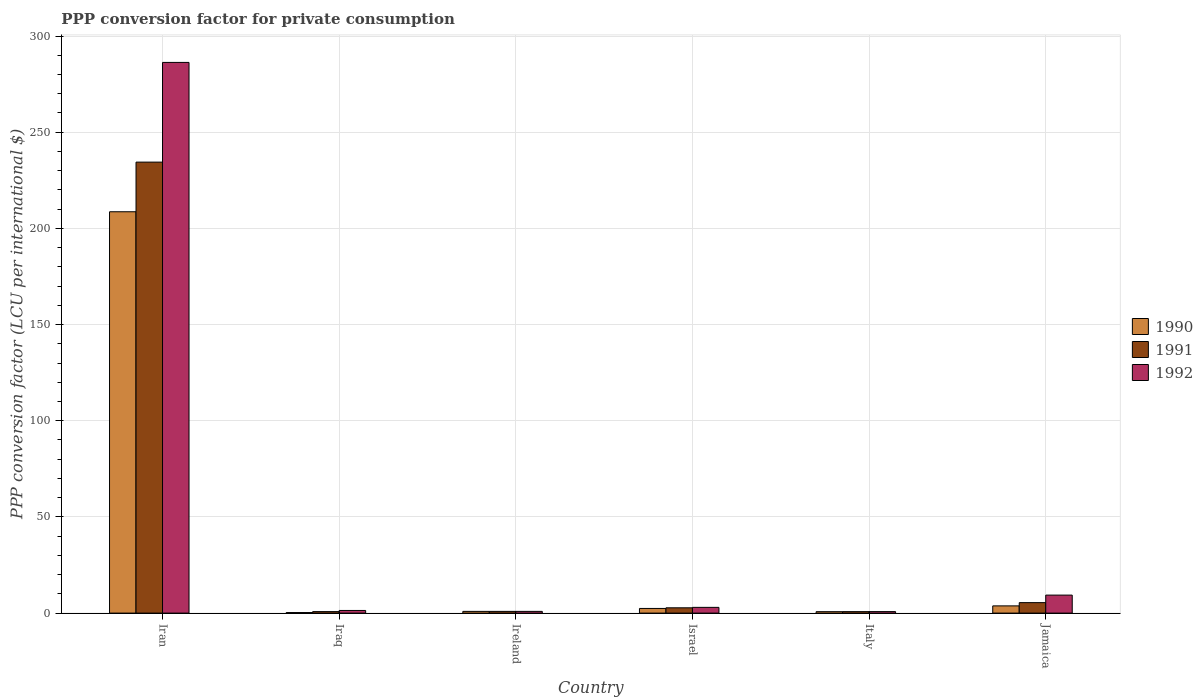Are the number of bars per tick equal to the number of legend labels?
Offer a terse response. Yes. How many bars are there on the 5th tick from the left?
Make the answer very short. 3. What is the label of the 3rd group of bars from the left?
Your answer should be very brief. Ireland. In how many cases, is the number of bars for a given country not equal to the number of legend labels?
Offer a terse response. 0. What is the PPP conversion factor for private consumption in 1991 in Jamaica?
Your response must be concise. 5.44. Across all countries, what is the maximum PPP conversion factor for private consumption in 1990?
Provide a succinct answer. 208.65. Across all countries, what is the minimum PPP conversion factor for private consumption in 1992?
Ensure brevity in your answer.  0.78. In which country was the PPP conversion factor for private consumption in 1990 maximum?
Offer a terse response. Iran. In which country was the PPP conversion factor for private consumption in 1991 minimum?
Your response must be concise. Italy. What is the total PPP conversion factor for private consumption in 1991 in the graph?
Make the answer very short. 245.06. What is the difference between the PPP conversion factor for private consumption in 1991 in Iran and that in Iraq?
Your response must be concise. 233.69. What is the difference between the PPP conversion factor for private consumption in 1990 in Israel and the PPP conversion factor for private consumption in 1992 in Jamaica?
Offer a terse response. -6.94. What is the average PPP conversion factor for private consumption in 1991 per country?
Your answer should be compact. 40.84. What is the difference between the PPP conversion factor for private consumption of/in 1991 and PPP conversion factor for private consumption of/in 1990 in Jamaica?
Ensure brevity in your answer.  1.69. In how many countries, is the PPP conversion factor for private consumption in 1992 greater than 100 LCU?
Your answer should be compact. 1. What is the ratio of the PPP conversion factor for private consumption in 1990 in Iran to that in Iraq?
Offer a very short reply. 731.55. Is the difference between the PPP conversion factor for private consumption in 1991 in Israel and Italy greater than the difference between the PPP conversion factor for private consumption in 1990 in Israel and Italy?
Your answer should be very brief. Yes. What is the difference between the highest and the second highest PPP conversion factor for private consumption in 1991?
Give a very brief answer. 231.71. What is the difference between the highest and the lowest PPP conversion factor for private consumption in 1991?
Make the answer very short. 233.7. In how many countries, is the PPP conversion factor for private consumption in 1990 greater than the average PPP conversion factor for private consumption in 1990 taken over all countries?
Give a very brief answer. 1. Is the sum of the PPP conversion factor for private consumption in 1992 in Iraq and Israel greater than the maximum PPP conversion factor for private consumption in 1991 across all countries?
Your answer should be very brief. No. What does the 1st bar from the left in Israel represents?
Your answer should be very brief. 1990. What does the 2nd bar from the right in Italy represents?
Make the answer very short. 1991. Is it the case that in every country, the sum of the PPP conversion factor for private consumption in 1990 and PPP conversion factor for private consumption in 1991 is greater than the PPP conversion factor for private consumption in 1992?
Offer a very short reply. No. How many bars are there?
Your answer should be compact. 18. Are all the bars in the graph horizontal?
Your answer should be very brief. No. How many countries are there in the graph?
Your answer should be compact. 6. What is the difference between two consecutive major ticks on the Y-axis?
Give a very brief answer. 50. Are the values on the major ticks of Y-axis written in scientific E-notation?
Offer a terse response. No. Does the graph contain grids?
Give a very brief answer. Yes. What is the title of the graph?
Provide a succinct answer. PPP conversion factor for private consumption. Does "1982" appear as one of the legend labels in the graph?
Offer a very short reply. No. What is the label or title of the X-axis?
Provide a succinct answer. Country. What is the label or title of the Y-axis?
Your answer should be very brief. PPP conversion factor (LCU per international $). What is the PPP conversion factor (LCU per international $) of 1990 in Iran?
Your response must be concise. 208.65. What is the PPP conversion factor (LCU per international $) in 1991 in Iran?
Provide a short and direct response. 234.46. What is the PPP conversion factor (LCU per international $) of 1992 in Iran?
Your answer should be compact. 286.29. What is the PPP conversion factor (LCU per international $) of 1990 in Iraq?
Your answer should be very brief. 0.29. What is the PPP conversion factor (LCU per international $) of 1991 in Iraq?
Your answer should be compact. 0.77. What is the PPP conversion factor (LCU per international $) in 1992 in Iraq?
Your response must be concise. 1.37. What is the PPP conversion factor (LCU per international $) of 1990 in Ireland?
Keep it short and to the point. 0.9. What is the PPP conversion factor (LCU per international $) in 1991 in Ireland?
Provide a short and direct response. 0.89. What is the PPP conversion factor (LCU per international $) of 1992 in Ireland?
Give a very brief answer. 0.89. What is the PPP conversion factor (LCU per international $) of 1990 in Israel?
Offer a terse response. 2.42. What is the PPP conversion factor (LCU per international $) of 1991 in Israel?
Ensure brevity in your answer.  2.75. What is the PPP conversion factor (LCU per international $) in 1992 in Israel?
Keep it short and to the point. 2.98. What is the PPP conversion factor (LCU per international $) in 1990 in Italy?
Offer a very short reply. 0.73. What is the PPP conversion factor (LCU per international $) in 1991 in Italy?
Your answer should be very brief. 0.76. What is the PPP conversion factor (LCU per international $) of 1992 in Italy?
Offer a terse response. 0.78. What is the PPP conversion factor (LCU per international $) of 1990 in Jamaica?
Offer a terse response. 3.75. What is the PPP conversion factor (LCU per international $) in 1991 in Jamaica?
Make the answer very short. 5.44. What is the PPP conversion factor (LCU per international $) of 1992 in Jamaica?
Provide a short and direct response. 9.36. Across all countries, what is the maximum PPP conversion factor (LCU per international $) in 1990?
Provide a succinct answer. 208.65. Across all countries, what is the maximum PPP conversion factor (LCU per international $) of 1991?
Ensure brevity in your answer.  234.46. Across all countries, what is the maximum PPP conversion factor (LCU per international $) in 1992?
Offer a terse response. 286.29. Across all countries, what is the minimum PPP conversion factor (LCU per international $) in 1990?
Your answer should be compact. 0.29. Across all countries, what is the minimum PPP conversion factor (LCU per international $) of 1991?
Keep it short and to the point. 0.76. Across all countries, what is the minimum PPP conversion factor (LCU per international $) in 1992?
Your answer should be very brief. 0.78. What is the total PPP conversion factor (LCU per international $) of 1990 in the graph?
Your response must be concise. 216.73. What is the total PPP conversion factor (LCU per international $) of 1991 in the graph?
Provide a succinct answer. 245.06. What is the total PPP conversion factor (LCU per international $) in 1992 in the graph?
Give a very brief answer. 301.67. What is the difference between the PPP conversion factor (LCU per international $) of 1990 in Iran and that in Iraq?
Your answer should be very brief. 208.36. What is the difference between the PPP conversion factor (LCU per international $) of 1991 in Iran and that in Iraq?
Offer a terse response. 233.69. What is the difference between the PPP conversion factor (LCU per international $) in 1992 in Iran and that in Iraq?
Your response must be concise. 284.92. What is the difference between the PPP conversion factor (LCU per international $) of 1990 in Iran and that in Ireland?
Make the answer very short. 207.75. What is the difference between the PPP conversion factor (LCU per international $) in 1991 in Iran and that in Ireland?
Your answer should be compact. 233.57. What is the difference between the PPP conversion factor (LCU per international $) in 1992 in Iran and that in Ireland?
Keep it short and to the point. 285.4. What is the difference between the PPP conversion factor (LCU per international $) in 1990 in Iran and that in Israel?
Provide a succinct answer. 206.23. What is the difference between the PPP conversion factor (LCU per international $) in 1991 in Iran and that in Israel?
Give a very brief answer. 231.71. What is the difference between the PPP conversion factor (LCU per international $) of 1992 in Iran and that in Israel?
Ensure brevity in your answer.  283.31. What is the difference between the PPP conversion factor (LCU per international $) in 1990 in Iran and that in Italy?
Offer a terse response. 207.91. What is the difference between the PPP conversion factor (LCU per international $) of 1991 in Iran and that in Italy?
Your response must be concise. 233.7. What is the difference between the PPP conversion factor (LCU per international $) in 1992 in Iran and that in Italy?
Offer a very short reply. 285.51. What is the difference between the PPP conversion factor (LCU per international $) of 1990 in Iran and that in Jamaica?
Your response must be concise. 204.9. What is the difference between the PPP conversion factor (LCU per international $) of 1991 in Iran and that in Jamaica?
Make the answer very short. 229.02. What is the difference between the PPP conversion factor (LCU per international $) in 1992 in Iran and that in Jamaica?
Make the answer very short. 276.94. What is the difference between the PPP conversion factor (LCU per international $) of 1990 in Iraq and that in Ireland?
Your response must be concise. -0.61. What is the difference between the PPP conversion factor (LCU per international $) of 1991 in Iraq and that in Ireland?
Offer a terse response. -0.12. What is the difference between the PPP conversion factor (LCU per international $) in 1992 in Iraq and that in Ireland?
Your response must be concise. 0.48. What is the difference between the PPP conversion factor (LCU per international $) of 1990 in Iraq and that in Israel?
Keep it short and to the point. -2.13. What is the difference between the PPP conversion factor (LCU per international $) in 1991 in Iraq and that in Israel?
Offer a very short reply. -1.98. What is the difference between the PPP conversion factor (LCU per international $) of 1992 in Iraq and that in Israel?
Provide a succinct answer. -1.61. What is the difference between the PPP conversion factor (LCU per international $) in 1990 in Iraq and that in Italy?
Your answer should be compact. -0.45. What is the difference between the PPP conversion factor (LCU per international $) in 1991 in Iraq and that in Italy?
Offer a very short reply. 0.01. What is the difference between the PPP conversion factor (LCU per international $) in 1992 in Iraq and that in Italy?
Your answer should be compact. 0.59. What is the difference between the PPP conversion factor (LCU per international $) of 1990 in Iraq and that in Jamaica?
Ensure brevity in your answer.  -3.47. What is the difference between the PPP conversion factor (LCU per international $) in 1991 in Iraq and that in Jamaica?
Offer a terse response. -4.67. What is the difference between the PPP conversion factor (LCU per international $) in 1992 in Iraq and that in Jamaica?
Keep it short and to the point. -7.99. What is the difference between the PPP conversion factor (LCU per international $) of 1990 in Ireland and that in Israel?
Your response must be concise. -1.52. What is the difference between the PPP conversion factor (LCU per international $) of 1991 in Ireland and that in Israel?
Offer a terse response. -1.86. What is the difference between the PPP conversion factor (LCU per international $) in 1992 in Ireland and that in Israel?
Offer a terse response. -2.09. What is the difference between the PPP conversion factor (LCU per international $) in 1990 in Ireland and that in Italy?
Your response must be concise. 0.16. What is the difference between the PPP conversion factor (LCU per international $) in 1991 in Ireland and that in Italy?
Provide a succinct answer. 0.13. What is the difference between the PPP conversion factor (LCU per international $) of 1992 in Ireland and that in Italy?
Give a very brief answer. 0.12. What is the difference between the PPP conversion factor (LCU per international $) of 1990 in Ireland and that in Jamaica?
Provide a succinct answer. -2.86. What is the difference between the PPP conversion factor (LCU per international $) of 1991 in Ireland and that in Jamaica?
Offer a very short reply. -4.55. What is the difference between the PPP conversion factor (LCU per international $) of 1992 in Ireland and that in Jamaica?
Your answer should be compact. -8.46. What is the difference between the PPP conversion factor (LCU per international $) in 1990 in Israel and that in Italy?
Your answer should be compact. 1.69. What is the difference between the PPP conversion factor (LCU per international $) in 1991 in Israel and that in Italy?
Your answer should be compact. 1.99. What is the difference between the PPP conversion factor (LCU per international $) in 1992 in Israel and that in Italy?
Ensure brevity in your answer.  2.2. What is the difference between the PPP conversion factor (LCU per international $) of 1990 in Israel and that in Jamaica?
Provide a succinct answer. -1.33. What is the difference between the PPP conversion factor (LCU per international $) of 1991 in Israel and that in Jamaica?
Keep it short and to the point. -2.69. What is the difference between the PPP conversion factor (LCU per international $) in 1992 in Israel and that in Jamaica?
Offer a very short reply. -6.38. What is the difference between the PPP conversion factor (LCU per international $) of 1990 in Italy and that in Jamaica?
Make the answer very short. -3.02. What is the difference between the PPP conversion factor (LCU per international $) of 1991 in Italy and that in Jamaica?
Your response must be concise. -4.68. What is the difference between the PPP conversion factor (LCU per international $) of 1992 in Italy and that in Jamaica?
Keep it short and to the point. -8.58. What is the difference between the PPP conversion factor (LCU per international $) in 1990 in Iran and the PPP conversion factor (LCU per international $) in 1991 in Iraq?
Give a very brief answer. 207.88. What is the difference between the PPP conversion factor (LCU per international $) of 1990 in Iran and the PPP conversion factor (LCU per international $) of 1992 in Iraq?
Keep it short and to the point. 207.28. What is the difference between the PPP conversion factor (LCU per international $) in 1991 in Iran and the PPP conversion factor (LCU per international $) in 1992 in Iraq?
Keep it short and to the point. 233.09. What is the difference between the PPP conversion factor (LCU per international $) of 1990 in Iran and the PPP conversion factor (LCU per international $) of 1991 in Ireland?
Ensure brevity in your answer.  207.76. What is the difference between the PPP conversion factor (LCU per international $) in 1990 in Iran and the PPP conversion factor (LCU per international $) in 1992 in Ireland?
Keep it short and to the point. 207.75. What is the difference between the PPP conversion factor (LCU per international $) in 1991 in Iran and the PPP conversion factor (LCU per international $) in 1992 in Ireland?
Ensure brevity in your answer.  233.56. What is the difference between the PPP conversion factor (LCU per international $) of 1990 in Iran and the PPP conversion factor (LCU per international $) of 1991 in Israel?
Offer a terse response. 205.9. What is the difference between the PPP conversion factor (LCU per international $) in 1990 in Iran and the PPP conversion factor (LCU per international $) in 1992 in Israel?
Offer a terse response. 205.67. What is the difference between the PPP conversion factor (LCU per international $) of 1991 in Iran and the PPP conversion factor (LCU per international $) of 1992 in Israel?
Provide a succinct answer. 231.48. What is the difference between the PPP conversion factor (LCU per international $) of 1990 in Iran and the PPP conversion factor (LCU per international $) of 1991 in Italy?
Provide a succinct answer. 207.89. What is the difference between the PPP conversion factor (LCU per international $) in 1990 in Iran and the PPP conversion factor (LCU per international $) in 1992 in Italy?
Offer a very short reply. 207.87. What is the difference between the PPP conversion factor (LCU per international $) in 1991 in Iran and the PPP conversion factor (LCU per international $) in 1992 in Italy?
Make the answer very short. 233.68. What is the difference between the PPP conversion factor (LCU per international $) in 1990 in Iran and the PPP conversion factor (LCU per international $) in 1991 in Jamaica?
Ensure brevity in your answer.  203.21. What is the difference between the PPP conversion factor (LCU per international $) of 1990 in Iran and the PPP conversion factor (LCU per international $) of 1992 in Jamaica?
Offer a very short reply. 199.29. What is the difference between the PPP conversion factor (LCU per international $) in 1991 in Iran and the PPP conversion factor (LCU per international $) in 1992 in Jamaica?
Offer a very short reply. 225.1. What is the difference between the PPP conversion factor (LCU per international $) in 1990 in Iraq and the PPP conversion factor (LCU per international $) in 1991 in Ireland?
Give a very brief answer. -0.61. What is the difference between the PPP conversion factor (LCU per international $) in 1990 in Iraq and the PPP conversion factor (LCU per international $) in 1992 in Ireland?
Your answer should be very brief. -0.61. What is the difference between the PPP conversion factor (LCU per international $) in 1991 in Iraq and the PPP conversion factor (LCU per international $) in 1992 in Ireland?
Offer a very short reply. -0.12. What is the difference between the PPP conversion factor (LCU per international $) of 1990 in Iraq and the PPP conversion factor (LCU per international $) of 1991 in Israel?
Keep it short and to the point. -2.46. What is the difference between the PPP conversion factor (LCU per international $) of 1990 in Iraq and the PPP conversion factor (LCU per international $) of 1992 in Israel?
Ensure brevity in your answer.  -2.7. What is the difference between the PPP conversion factor (LCU per international $) in 1991 in Iraq and the PPP conversion factor (LCU per international $) in 1992 in Israel?
Keep it short and to the point. -2.21. What is the difference between the PPP conversion factor (LCU per international $) of 1990 in Iraq and the PPP conversion factor (LCU per international $) of 1991 in Italy?
Your response must be concise. -0.47. What is the difference between the PPP conversion factor (LCU per international $) in 1990 in Iraq and the PPP conversion factor (LCU per international $) in 1992 in Italy?
Provide a short and direct response. -0.49. What is the difference between the PPP conversion factor (LCU per international $) of 1991 in Iraq and the PPP conversion factor (LCU per international $) of 1992 in Italy?
Your answer should be compact. -0.01. What is the difference between the PPP conversion factor (LCU per international $) in 1990 in Iraq and the PPP conversion factor (LCU per international $) in 1991 in Jamaica?
Your response must be concise. -5.15. What is the difference between the PPP conversion factor (LCU per international $) of 1990 in Iraq and the PPP conversion factor (LCU per international $) of 1992 in Jamaica?
Your response must be concise. -9.07. What is the difference between the PPP conversion factor (LCU per international $) of 1991 in Iraq and the PPP conversion factor (LCU per international $) of 1992 in Jamaica?
Your answer should be compact. -8.59. What is the difference between the PPP conversion factor (LCU per international $) in 1990 in Ireland and the PPP conversion factor (LCU per international $) in 1991 in Israel?
Offer a very short reply. -1.85. What is the difference between the PPP conversion factor (LCU per international $) in 1990 in Ireland and the PPP conversion factor (LCU per international $) in 1992 in Israel?
Make the answer very short. -2.08. What is the difference between the PPP conversion factor (LCU per international $) of 1991 in Ireland and the PPP conversion factor (LCU per international $) of 1992 in Israel?
Ensure brevity in your answer.  -2.09. What is the difference between the PPP conversion factor (LCU per international $) in 1990 in Ireland and the PPP conversion factor (LCU per international $) in 1991 in Italy?
Offer a terse response. 0.14. What is the difference between the PPP conversion factor (LCU per international $) of 1990 in Ireland and the PPP conversion factor (LCU per international $) of 1992 in Italy?
Offer a terse response. 0.12. What is the difference between the PPP conversion factor (LCU per international $) in 1991 in Ireland and the PPP conversion factor (LCU per international $) in 1992 in Italy?
Give a very brief answer. 0.11. What is the difference between the PPP conversion factor (LCU per international $) of 1990 in Ireland and the PPP conversion factor (LCU per international $) of 1991 in Jamaica?
Keep it short and to the point. -4.54. What is the difference between the PPP conversion factor (LCU per international $) in 1990 in Ireland and the PPP conversion factor (LCU per international $) in 1992 in Jamaica?
Make the answer very short. -8.46. What is the difference between the PPP conversion factor (LCU per international $) in 1991 in Ireland and the PPP conversion factor (LCU per international $) in 1992 in Jamaica?
Offer a terse response. -8.47. What is the difference between the PPP conversion factor (LCU per international $) in 1990 in Israel and the PPP conversion factor (LCU per international $) in 1991 in Italy?
Provide a short and direct response. 1.66. What is the difference between the PPP conversion factor (LCU per international $) of 1990 in Israel and the PPP conversion factor (LCU per international $) of 1992 in Italy?
Your answer should be very brief. 1.64. What is the difference between the PPP conversion factor (LCU per international $) in 1991 in Israel and the PPP conversion factor (LCU per international $) in 1992 in Italy?
Provide a succinct answer. 1.97. What is the difference between the PPP conversion factor (LCU per international $) of 1990 in Israel and the PPP conversion factor (LCU per international $) of 1991 in Jamaica?
Make the answer very short. -3.02. What is the difference between the PPP conversion factor (LCU per international $) in 1990 in Israel and the PPP conversion factor (LCU per international $) in 1992 in Jamaica?
Offer a terse response. -6.94. What is the difference between the PPP conversion factor (LCU per international $) in 1991 in Israel and the PPP conversion factor (LCU per international $) in 1992 in Jamaica?
Your answer should be very brief. -6.61. What is the difference between the PPP conversion factor (LCU per international $) of 1990 in Italy and the PPP conversion factor (LCU per international $) of 1991 in Jamaica?
Offer a very short reply. -4.7. What is the difference between the PPP conversion factor (LCU per international $) in 1990 in Italy and the PPP conversion factor (LCU per international $) in 1992 in Jamaica?
Offer a very short reply. -8.62. What is the difference between the PPP conversion factor (LCU per international $) in 1991 in Italy and the PPP conversion factor (LCU per international $) in 1992 in Jamaica?
Make the answer very short. -8.6. What is the average PPP conversion factor (LCU per international $) of 1990 per country?
Ensure brevity in your answer.  36.12. What is the average PPP conversion factor (LCU per international $) in 1991 per country?
Your answer should be very brief. 40.84. What is the average PPP conversion factor (LCU per international $) of 1992 per country?
Your answer should be compact. 50.28. What is the difference between the PPP conversion factor (LCU per international $) in 1990 and PPP conversion factor (LCU per international $) in 1991 in Iran?
Give a very brief answer. -25.81. What is the difference between the PPP conversion factor (LCU per international $) of 1990 and PPP conversion factor (LCU per international $) of 1992 in Iran?
Your response must be concise. -77.65. What is the difference between the PPP conversion factor (LCU per international $) in 1991 and PPP conversion factor (LCU per international $) in 1992 in Iran?
Keep it short and to the point. -51.84. What is the difference between the PPP conversion factor (LCU per international $) of 1990 and PPP conversion factor (LCU per international $) of 1991 in Iraq?
Give a very brief answer. -0.48. What is the difference between the PPP conversion factor (LCU per international $) of 1990 and PPP conversion factor (LCU per international $) of 1992 in Iraq?
Make the answer very short. -1.08. What is the difference between the PPP conversion factor (LCU per international $) of 1991 and PPP conversion factor (LCU per international $) of 1992 in Iraq?
Give a very brief answer. -0.6. What is the difference between the PPP conversion factor (LCU per international $) of 1990 and PPP conversion factor (LCU per international $) of 1991 in Ireland?
Offer a terse response. 0.01. What is the difference between the PPP conversion factor (LCU per international $) in 1990 and PPP conversion factor (LCU per international $) in 1992 in Ireland?
Give a very brief answer. 0. What is the difference between the PPP conversion factor (LCU per international $) of 1991 and PPP conversion factor (LCU per international $) of 1992 in Ireland?
Provide a short and direct response. -0. What is the difference between the PPP conversion factor (LCU per international $) in 1990 and PPP conversion factor (LCU per international $) in 1991 in Israel?
Your answer should be very brief. -0.33. What is the difference between the PPP conversion factor (LCU per international $) of 1990 and PPP conversion factor (LCU per international $) of 1992 in Israel?
Your response must be concise. -0.56. What is the difference between the PPP conversion factor (LCU per international $) of 1991 and PPP conversion factor (LCU per international $) of 1992 in Israel?
Make the answer very short. -0.23. What is the difference between the PPP conversion factor (LCU per international $) of 1990 and PPP conversion factor (LCU per international $) of 1991 in Italy?
Provide a succinct answer. -0.03. What is the difference between the PPP conversion factor (LCU per international $) in 1990 and PPP conversion factor (LCU per international $) in 1992 in Italy?
Provide a short and direct response. -0.04. What is the difference between the PPP conversion factor (LCU per international $) in 1991 and PPP conversion factor (LCU per international $) in 1992 in Italy?
Your answer should be very brief. -0.02. What is the difference between the PPP conversion factor (LCU per international $) of 1990 and PPP conversion factor (LCU per international $) of 1991 in Jamaica?
Offer a very short reply. -1.69. What is the difference between the PPP conversion factor (LCU per international $) in 1990 and PPP conversion factor (LCU per international $) in 1992 in Jamaica?
Your answer should be very brief. -5.6. What is the difference between the PPP conversion factor (LCU per international $) in 1991 and PPP conversion factor (LCU per international $) in 1992 in Jamaica?
Offer a very short reply. -3.92. What is the ratio of the PPP conversion factor (LCU per international $) in 1990 in Iran to that in Iraq?
Provide a short and direct response. 731.55. What is the ratio of the PPP conversion factor (LCU per international $) of 1991 in Iran to that in Iraq?
Offer a very short reply. 304.98. What is the ratio of the PPP conversion factor (LCU per international $) in 1992 in Iran to that in Iraq?
Offer a terse response. 208.96. What is the ratio of the PPP conversion factor (LCU per international $) of 1990 in Iran to that in Ireland?
Ensure brevity in your answer.  232.98. What is the ratio of the PPP conversion factor (LCU per international $) of 1991 in Iran to that in Ireland?
Your answer should be compact. 263.33. What is the ratio of the PPP conversion factor (LCU per international $) in 1992 in Iran to that in Ireland?
Provide a succinct answer. 320.57. What is the ratio of the PPP conversion factor (LCU per international $) in 1990 in Iran to that in Israel?
Provide a succinct answer. 86.25. What is the ratio of the PPP conversion factor (LCU per international $) in 1991 in Iran to that in Israel?
Your answer should be very brief. 85.31. What is the ratio of the PPP conversion factor (LCU per international $) of 1992 in Iran to that in Israel?
Ensure brevity in your answer.  96.06. What is the ratio of the PPP conversion factor (LCU per international $) in 1990 in Iran to that in Italy?
Your answer should be compact. 284.47. What is the ratio of the PPP conversion factor (LCU per international $) in 1991 in Iran to that in Italy?
Ensure brevity in your answer.  308.85. What is the ratio of the PPP conversion factor (LCU per international $) of 1992 in Iran to that in Italy?
Your answer should be very brief. 368.1. What is the ratio of the PPP conversion factor (LCU per international $) of 1990 in Iran to that in Jamaica?
Provide a short and direct response. 55.62. What is the ratio of the PPP conversion factor (LCU per international $) of 1991 in Iran to that in Jamaica?
Offer a very short reply. 43.12. What is the ratio of the PPP conversion factor (LCU per international $) in 1992 in Iran to that in Jamaica?
Offer a terse response. 30.6. What is the ratio of the PPP conversion factor (LCU per international $) of 1990 in Iraq to that in Ireland?
Provide a succinct answer. 0.32. What is the ratio of the PPP conversion factor (LCU per international $) of 1991 in Iraq to that in Ireland?
Keep it short and to the point. 0.86. What is the ratio of the PPP conversion factor (LCU per international $) in 1992 in Iraq to that in Ireland?
Offer a terse response. 1.53. What is the ratio of the PPP conversion factor (LCU per international $) of 1990 in Iraq to that in Israel?
Provide a short and direct response. 0.12. What is the ratio of the PPP conversion factor (LCU per international $) of 1991 in Iraq to that in Israel?
Your response must be concise. 0.28. What is the ratio of the PPP conversion factor (LCU per international $) in 1992 in Iraq to that in Israel?
Offer a terse response. 0.46. What is the ratio of the PPP conversion factor (LCU per international $) of 1990 in Iraq to that in Italy?
Give a very brief answer. 0.39. What is the ratio of the PPP conversion factor (LCU per international $) of 1991 in Iraq to that in Italy?
Provide a succinct answer. 1.01. What is the ratio of the PPP conversion factor (LCU per international $) of 1992 in Iraq to that in Italy?
Your answer should be very brief. 1.76. What is the ratio of the PPP conversion factor (LCU per international $) in 1990 in Iraq to that in Jamaica?
Ensure brevity in your answer.  0.08. What is the ratio of the PPP conversion factor (LCU per international $) of 1991 in Iraq to that in Jamaica?
Provide a succinct answer. 0.14. What is the ratio of the PPP conversion factor (LCU per international $) of 1992 in Iraq to that in Jamaica?
Give a very brief answer. 0.15. What is the ratio of the PPP conversion factor (LCU per international $) in 1990 in Ireland to that in Israel?
Ensure brevity in your answer.  0.37. What is the ratio of the PPP conversion factor (LCU per international $) in 1991 in Ireland to that in Israel?
Make the answer very short. 0.32. What is the ratio of the PPP conversion factor (LCU per international $) of 1992 in Ireland to that in Israel?
Make the answer very short. 0.3. What is the ratio of the PPP conversion factor (LCU per international $) in 1990 in Ireland to that in Italy?
Provide a succinct answer. 1.22. What is the ratio of the PPP conversion factor (LCU per international $) in 1991 in Ireland to that in Italy?
Your response must be concise. 1.17. What is the ratio of the PPP conversion factor (LCU per international $) of 1992 in Ireland to that in Italy?
Provide a succinct answer. 1.15. What is the ratio of the PPP conversion factor (LCU per international $) in 1990 in Ireland to that in Jamaica?
Give a very brief answer. 0.24. What is the ratio of the PPP conversion factor (LCU per international $) in 1991 in Ireland to that in Jamaica?
Provide a succinct answer. 0.16. What is the ratio of the PPP conversion factor (LCU per international $) in 1992 in Ireland to that in Jamaica?
Your answer should be very brief. 0.1. What is the ratio of the PPP conversion factor (LCU per international $) of 1990 in Israel to that in Italy?
Your response must be concise. 3.3. What is the ratio of the PPP conversion factor (LCU per international $) of 1991 in Israel to that in Italy?
Offer a terse response. 3.62. What is the ratio of the PPP conversion factor (LCU per international $) in 1992 in Israel to that in Italy?
Offer a terse response. 3.83. What is the ratio of the PPP conversion factor (LCU per international $) in 1990 in Israel to that in Jamaica?
Your response must be concise. 0.64. What is the ratio of the PPP conversion factor (LCU per international $) in 1991 in Israel to that in Jamaica?
Ensure brevity in your answer.  0.51. What is the ratio of the PPP conversion factor (LCU per international $) in 1992 in Israel to that in Jamaica?
Offer a terse response. 0.32. What is the ratio of the PPP conversion factor (LCU per international $) of 1990 in Italy to that in Jamaica?
Give a very brief answer. 0.2. What is the ratio of the PPP conversion factor (LCU per international $) in 1991 in Italy to that in Jamaica?
Provide a succinct answer. 0.14. What is the ratio of the PPP conversion factor (LCU per international $) in 1992 in Italy to that in Jamaica?
Your answer should be compact. 0.08. What is the difference between the highest and the second highest PPP conversion factor (LCU per international $) of 1990?
Your answer should be compact. 204.9. What is the difference between the highest and the second highest PPP conversion factor (LCU per international $) of 1991?
Your answer should be compact. 229.02. What is the difference between the highest and the second highest PPP conversion factor (LCU per international $) of 1992?
Your answer should be very brief. 276.94. What is the difference between the highest and the lowest PPP conversion factor (LCU per international $) of 1990?
Your answer should be very brief. 208.36. What is the difference between the highest and the lowest PPP conversion factor (LCU per international $) of 1991?
Ensure brevity in your answer.  233.7. What is the difference between the highest and the lowest PPP conversion factor (LCU per international $) in 1992?
Offer a terse response. 285.51. 